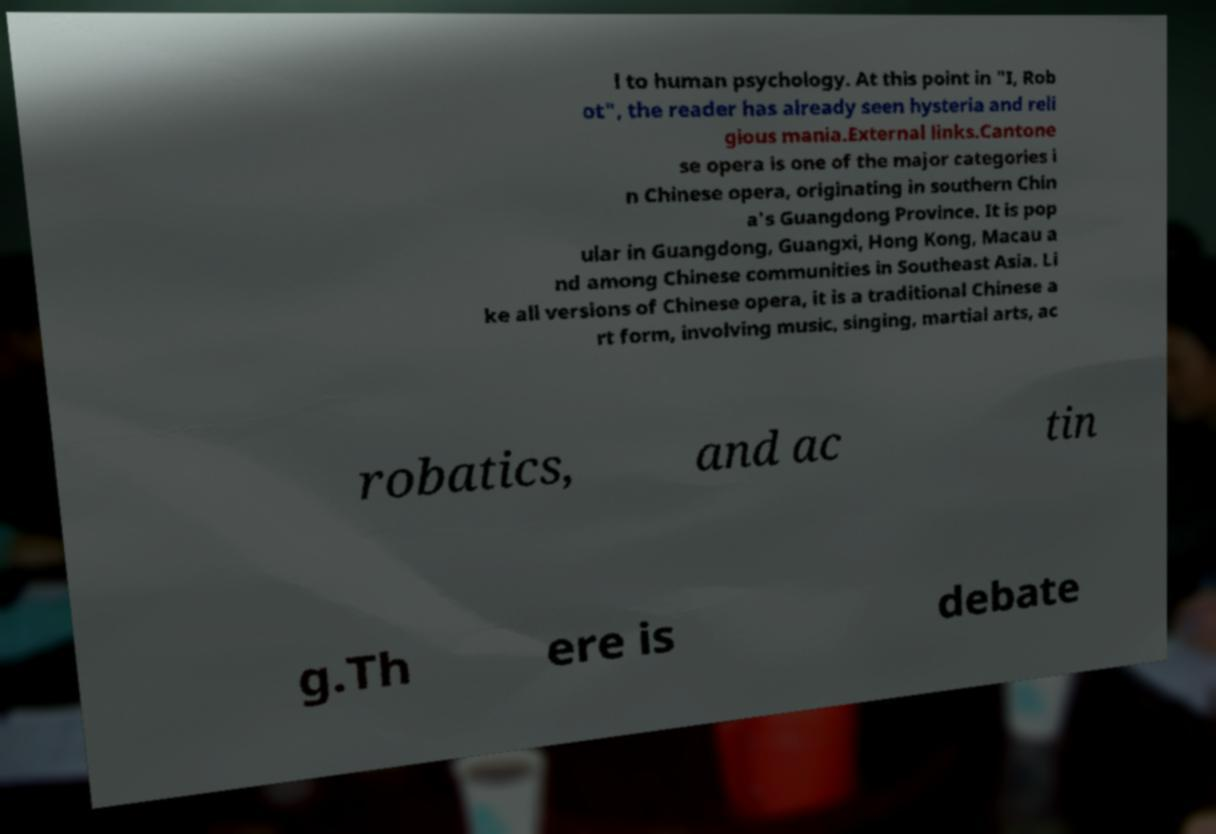For documentation purposes, I need the text within this image transcribed. Could you provide that? l to human psychology. At this point in "I, Rob ot", the reader has already seen hysteria and reli gious mania.External links.Cantone se opera is one of the major categories i n Chinese opera, originating in southern Chin a's Guangdong Province. It is pop ular in Guangdong, Guangxi, Hong Kong, Macau a nd among Chinese communities in Southeast Asia. Li ke all versions of Chinese opera, it is a traditional Chinese a rt form, involving music, singing, martial arts, ac robatics, and ac tin g.Th ere is debate 